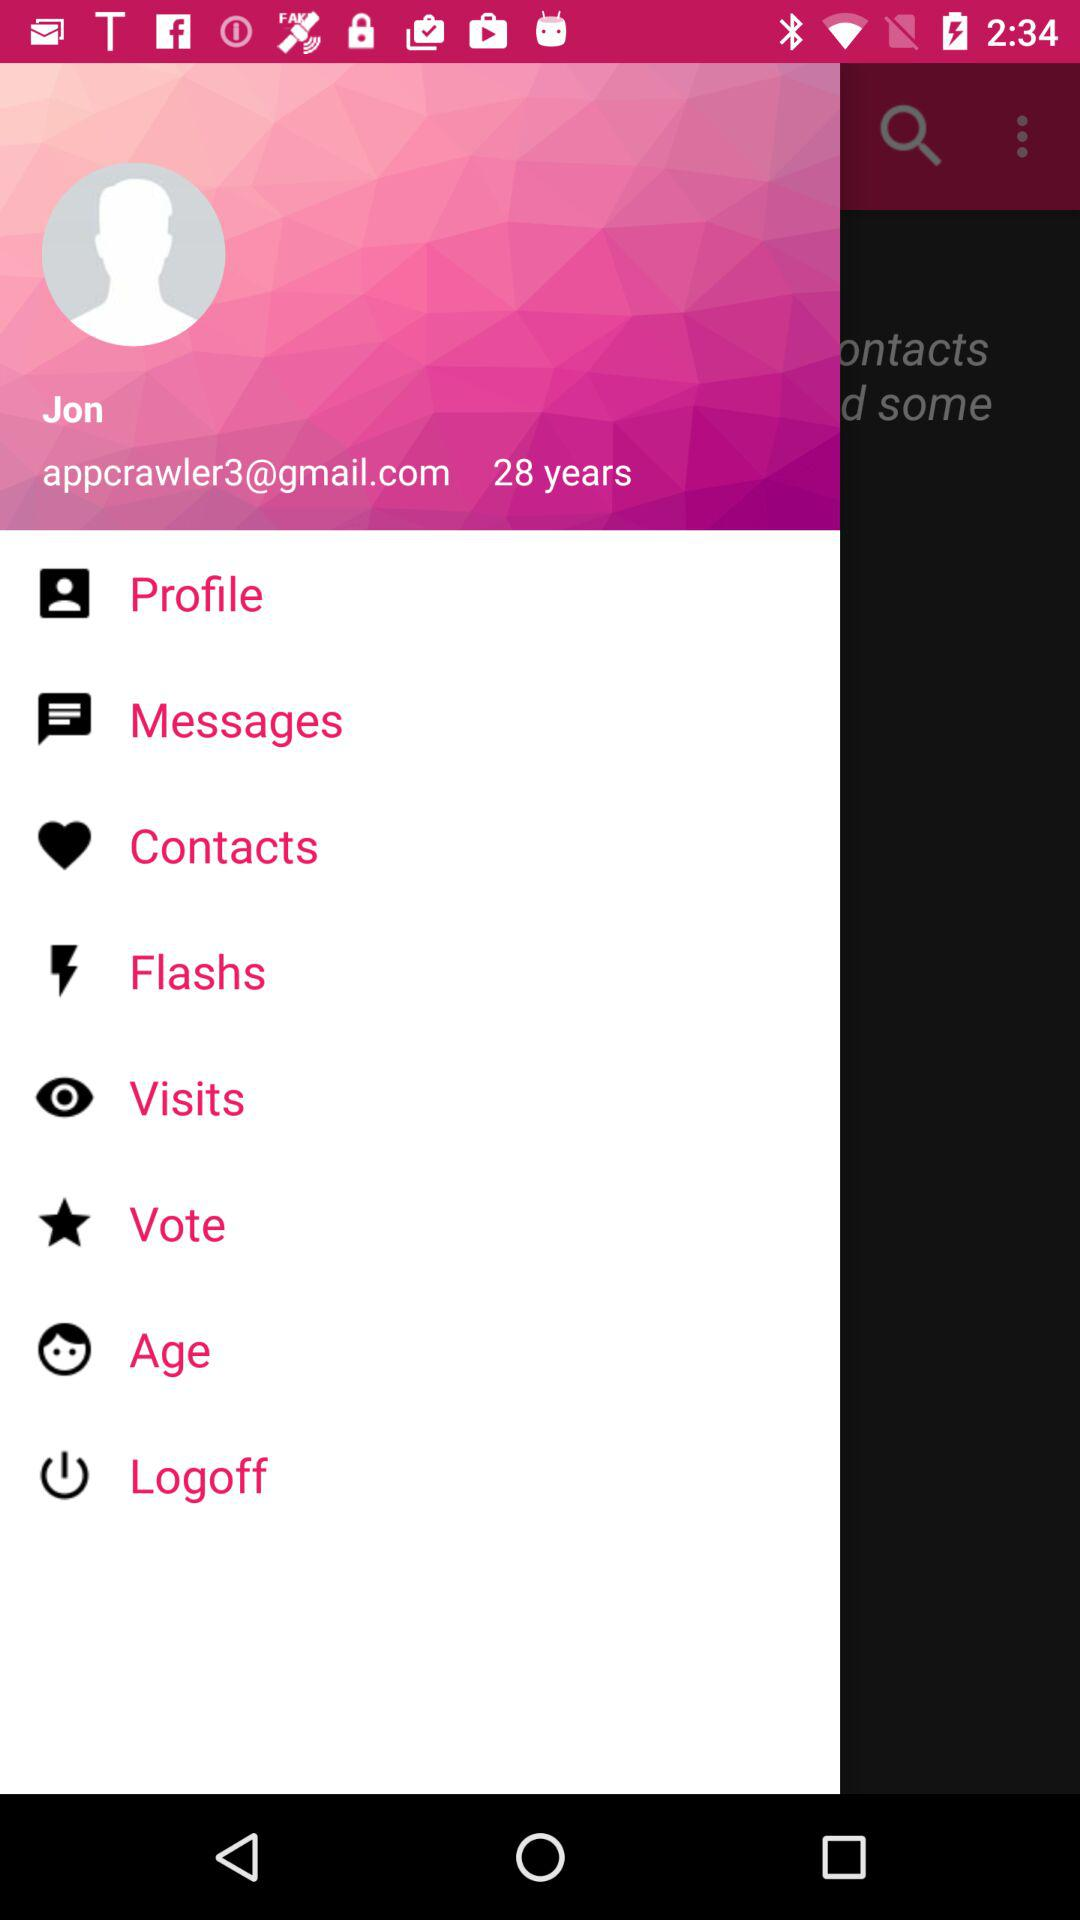What is the age of the user? The age of the user is 28 years old. 